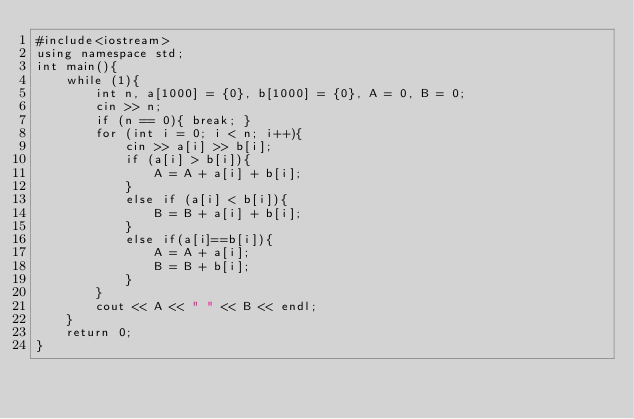Convert code to text. <code><loc_0><loc_0><loc_500><loc_500><_C++_>#include<iostream>
using namespace std;
int main(){
	while (1){
		int n, a[1000] = {0}, b[1000] = {0}, A = 0, B = 0;
		cin >> n;
		if (n == 0){ break; }
		for (int i = 0; i < n; i++){
			cin >> a[i] >> b[i];
			if (a[i] > b[i]){
				A = A + a[i] + b[i];
			}
			else if (a[i] < b[i]){
				B = B + a[i] + b[i];
			}
			else if(a[i]==b[i]){
				A = A + a[i];
				B = B + b[i];
			}
		}
		cout << A << " " << B << endl;
	}
	return 0;
}</code> 